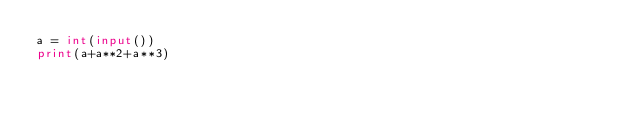<code> <loc_0><loc_0><loc_500><loc_500><_Python_>a = int(input())
print(a+a**2+a**3)</code> 